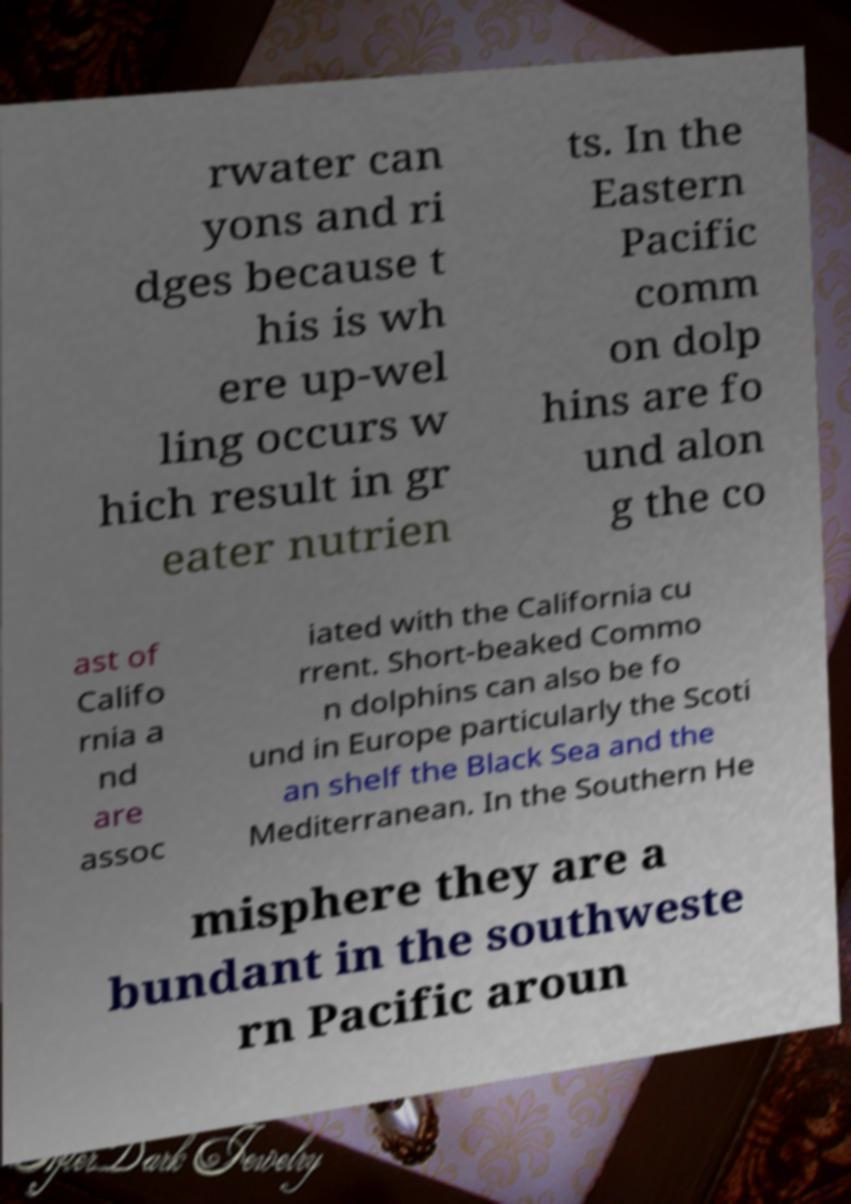Could you assist in decoding the text presented in this image and type it out clearly? rwater can yons and ri dges because t his is wh ere up-wel ling occurs w hich result in gr eater nutrien ts. In the Eastern Pacific comm on dolp hins are fo und alon g the co ast of Califo rnia a nd are assoc iated with the California cu rrent. Short-beaked Commo n dolphins can also be fo und in Europe particularly the Scoti an shelf the Black Sea and the Mediterranean. In the Southern He misphere they are a bundant in the southweste rn Pacific aroun 